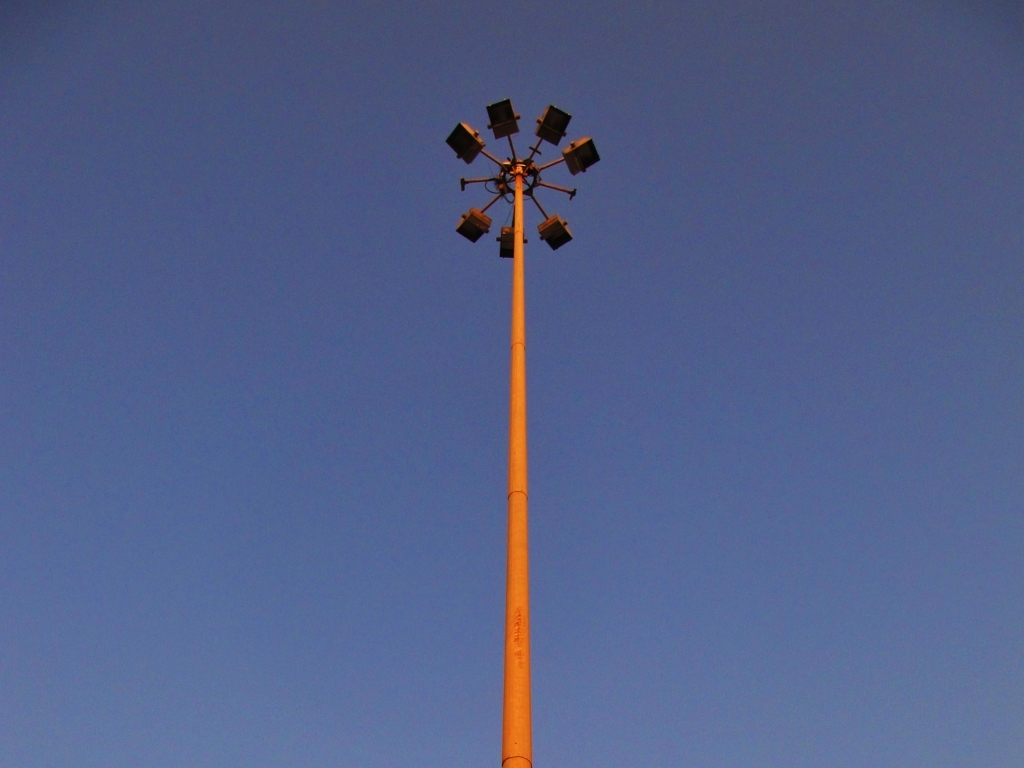Can you guess the location where this photo was taken? While it's challenging to determine the exact location without additional context, the designed function of the floodlights and the clear sky could point to a suburban or semi-urban area, possibly near a sports complex or public park. Are there any indicators of the specific country or region? Without distinct geographical markers, architecture, or signs, it's not possible to accurately determine the country or region from this image alone. 